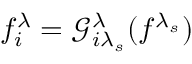<formula> <loc_0><loc_0><loc_500><loc_500>f _ { i } ^ { \lambda } = \mathcal { G } _ { i \lambda _ { s } } ^ { \lambda } ( f ^ { \lambda _ { s } } )</formula> 